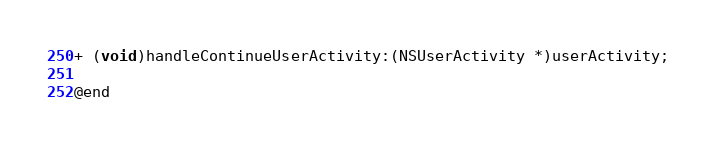<code> <loc_0><loc_0><loc_500><loc_500><_C_>+ (void)handleContinueUserActivity:(NSUserActivity *)userActivity;

@end
</code> 